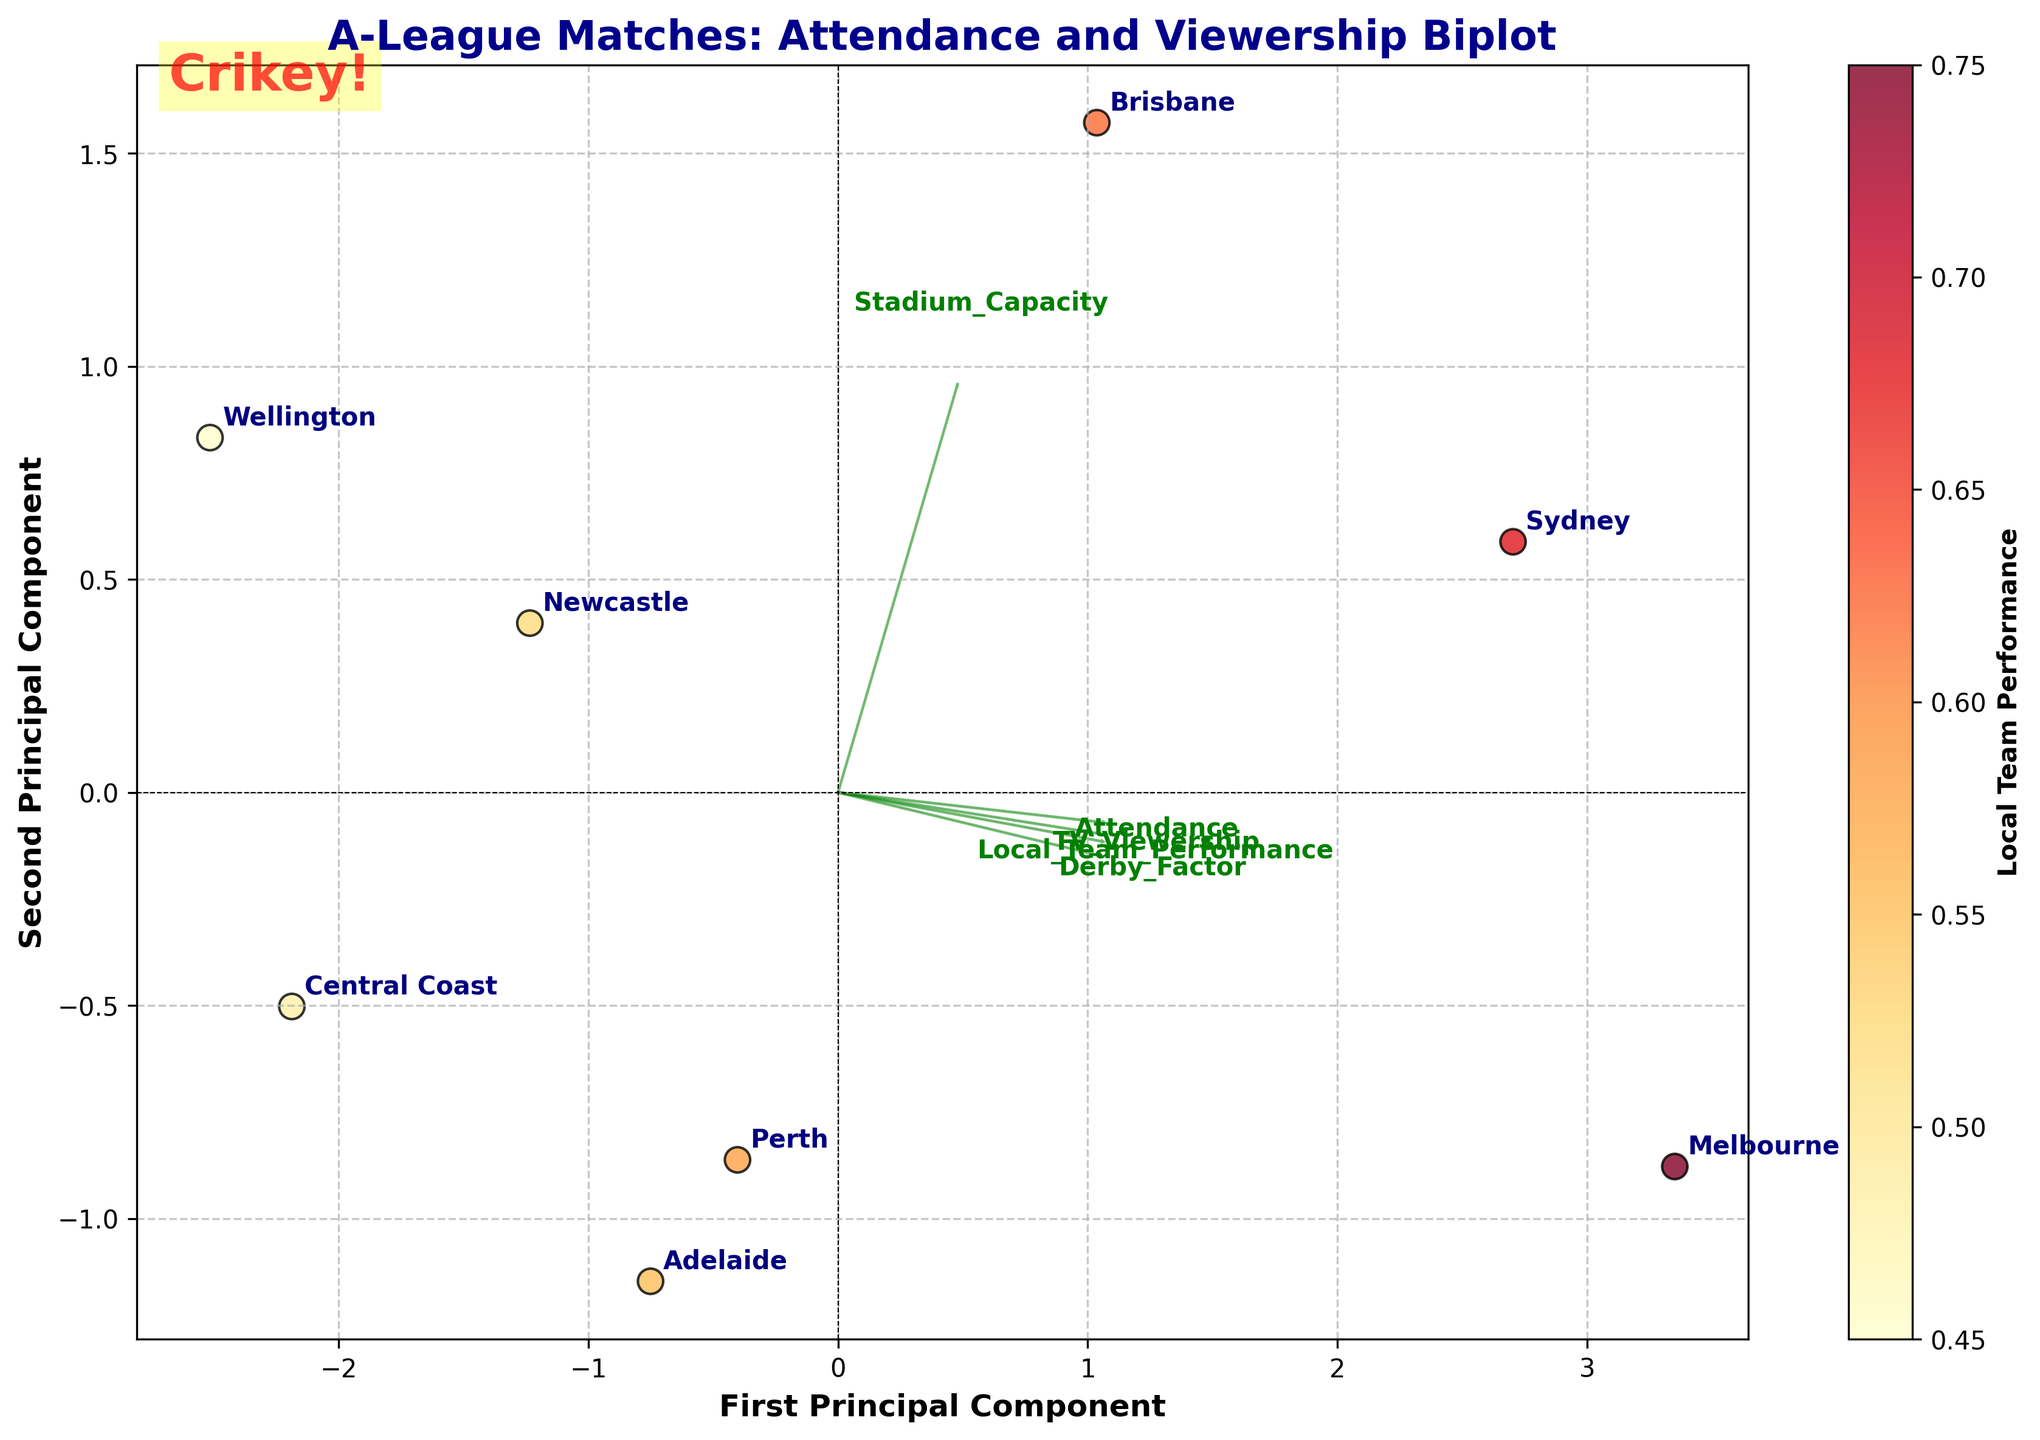What's the title of the biplot? The title of the plot is generally located at the top center of the figure. The specific title in this case is "A-League Matches: Attendance and Viewership Biplot."
Answer: A-League Matches: Attendance and Viewership Biplot Which city has the highest attendance? Identify the city that is furthest along the positive side of the "Attendance" loading vector. According to the information, Melbourne is positioned highest on the Attendance axis.
Answer: Melbourne How many arrows (loading vectors) are shown on the plot? Count the arrows originating from the center (0,0) to understand the loading vectors of the Principal Components. Five features in the dataset lead to five arrows.
Answer: 5 Which feature has the most influence on the first principal component? Look for the loading vector with the largest projection along the first principal component. The feature with the greatest length in the x-axis direction in the plot is "TV_Viewership."
Answer: TV_Viewership Which feature shows the least influence on both principal components? Find the shortest arrow among the loading vectors, indicating the least contribution to the overall variation. "Derby_Factor" appears to be the shortest vector.
Answer: Derby_Factor How is local team performance visually represented in the plot? Examine the color scheme or other visual cues. In the plot, local team performance is represented by the color intensity with a colorbar indicating performance levels.
Answer: By color intensity Which city has the lowest TV viewership relative to its attendance? Compare the positioning on the "TV_Viewership" vector relative to "Attendance." Wellington appears to be the lowest in TV viewership while not necessarily high in attendance.
Answer: Wellington What is the relationship between stadium capacity and attendance for Sydney? Look at Sydney's position relative to the vectors for "Stadium_Capacity" and "Attendance." Sydney shows a high positive projection on the "Stadium_Capacity" vector but not the highest on "Attendance," indicating its large stadium capacity relative to actual attendance.
Answer: High stadium capacity, moderate attendance Which city has the closest local team performance to Melbourne? Look at the color intensity of different points, aiming to match Melbourne's color. Sydney shows a color indicating local team performance close to Melbourne.
Answer: Sydney Are there any cities where both attendance and TV viewership are below average? Positions below average in both principal components' loading vectors indicate lower scores in "Attendance" and "TV_Viewership." Central Coast fits this description.
Answer: Central Coast 